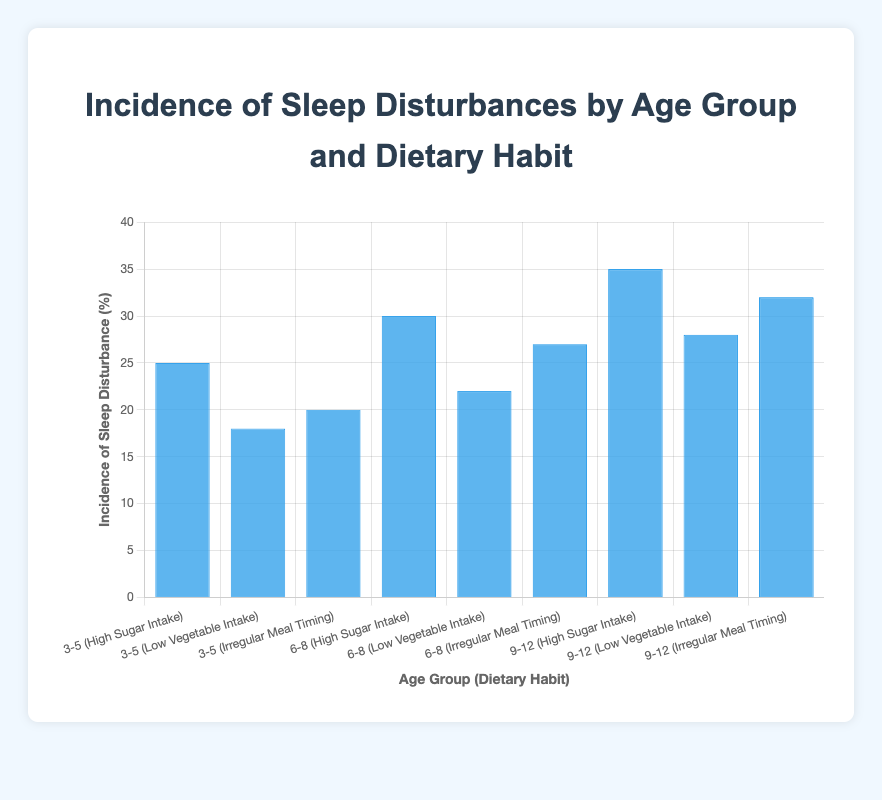What is the incidence of sleep disturbances for the age group 3-5 with high sugar intake? Look at the bar representing the age group 3-5 and dietary habit 'High Sugar Intake' and see the height of the bar or the label value on top of it, which shows 25.
Answer: 25 Which age group and dietary habit combination has the highest incidence of sleep disturbances? Identify the highest bar in the figure. The highest value is 35, which corresponds to the age group 9-12 with 'High Sugar Intake'.
Answer: 9-12 with High Sugar Intake How much higher is the incidence of sleep disturbances in age group 9-12 with irregular meal timing compared to age group 3-5 with the same dietary habit? Find the bars for the age groups 9-12 and 3-5 with 'Irregular Meal Timing'. The values are 32 and 20, respectively. Calculate the difference: 32 - 20 = 12.
Answer: 12 What is the average incidence of sleep disturbances for the dietary habit of low vegetable intake across all age groups? Find the values for 'Low Vegetable Intake' across all age groups: 18 (3-5), 22 (6-8), and 28 (9-12). Calculate the average: (18 + 22 + 28) / 3 = 68 / 3 ≈ 22.67.
Answer: 22.67 Is the incidence of sleep disturbances higher for age group 6-8 with high sugar intake or age group 9-12 with low vegetable intake? Compare the bars for 'High Sugar Intake' for age group 6-8 (30) and 'Low Vegetable Intake' for age group 9-12 (28). 30 is higher than 28.
Answer: Age group 6-8 with high sugar intake What’s the total incidence of sleep disturbances for children aged 3-8 with low vegetable intake? Sum the values for 'Low Vegetable Intake' in age groups 3-5 and 6-8. The values are 18 and 22, respectively. 18 + 22 = 40.
Answer: 40 Which dietary habit shows the most variation in incidence of sleep disturbances across the different age groups? Compare the range of values (difference between highest and lowest) for each dietary habit across all age groups. 'High Sugar Intake' ranges from 25 to 35 (range = 10), 'Low Vegetable Intake' ranges from 18 to 28 (range = 10), and 'Irregular Meal Timing' ranges from 20 to 32 (range = 12). The greatest range is for 'Irregular Meal Timing'.
Answer: Irregular Meal Timing 